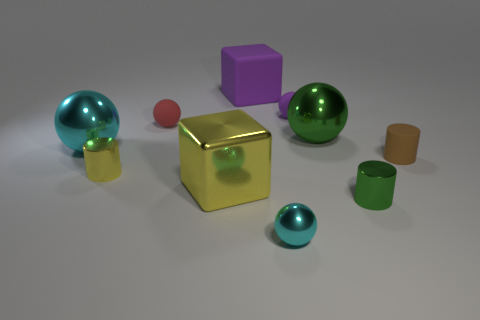What number of other things are there of the same size as the green metal cylinder?
Provide a succinct answer. 5. What is the size of the yellow cylinder?
Make the answer very short. Small. Do the green object that is right of the large green metallic thing and the large purple cube have the same material?
Offer a very short reply. No. There is another tiny rubber thing that is the same shape as the tiny red thing; what is its color?
Provide a short and direct response. Purple. There is a big metallic ball that is in front of the large green thing; does it have the same color as the tiny metallic sphere?
Provide a succinct answer. Yes. There is a small purple rubber thing; are there any small cylinders to the left of it?
Provide a succinct answer. Yes. What color is the tiny metal object that is to the left of the green shiny cylinder and to the right of the small yellow cylinder?
Your answer should be very brief. Cyan. What shape is the rubber thing that is the same color as the rubber cube?
Your answer should be very brief. Sphere. There is a sphere that is in front of the cyan metallic thing that is behind the small brown object; what is its size?
Offer a terse response. Small. What number of cylinders are either big yellow metallic things or green rubber things?
Make the answer very short. 0. 